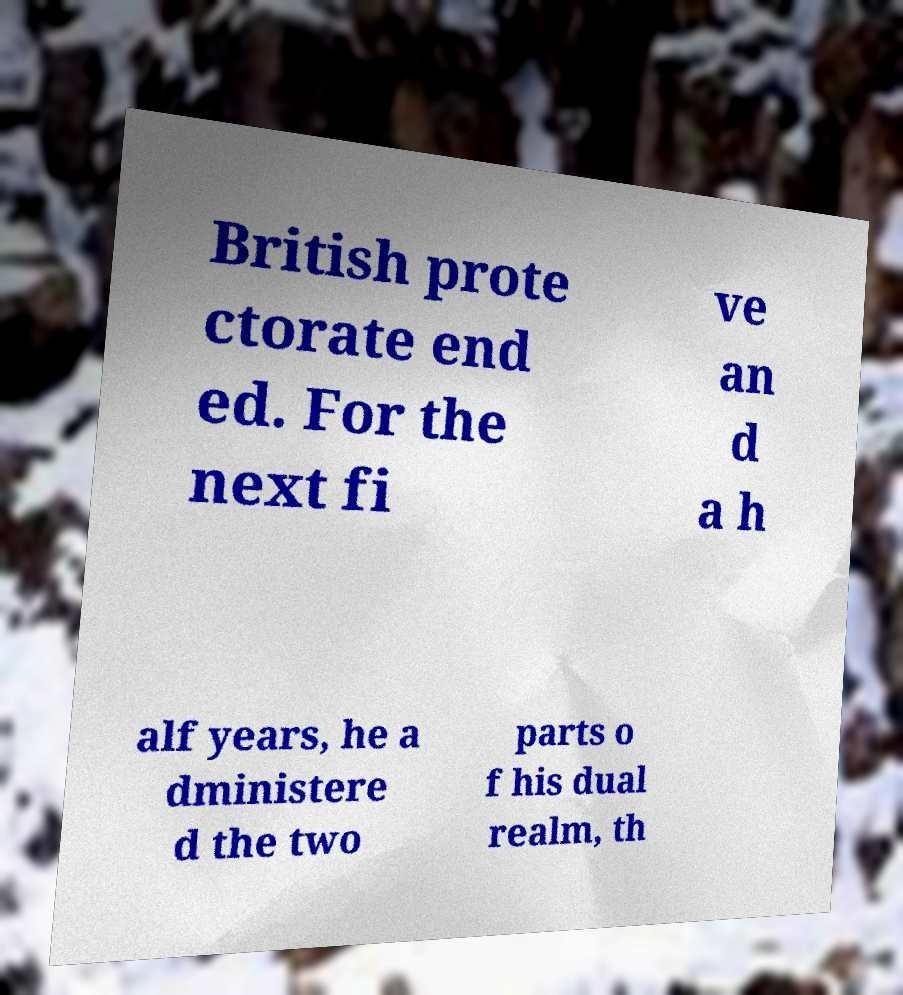Can you read and provide the text displayed in the image?This photo seems to have some interesting text. Can you extract and type it out for me? British prote ctorate end ed. For the next fi ve an d a h alf years, he a dministere d the two parts o f his dual realm, th 